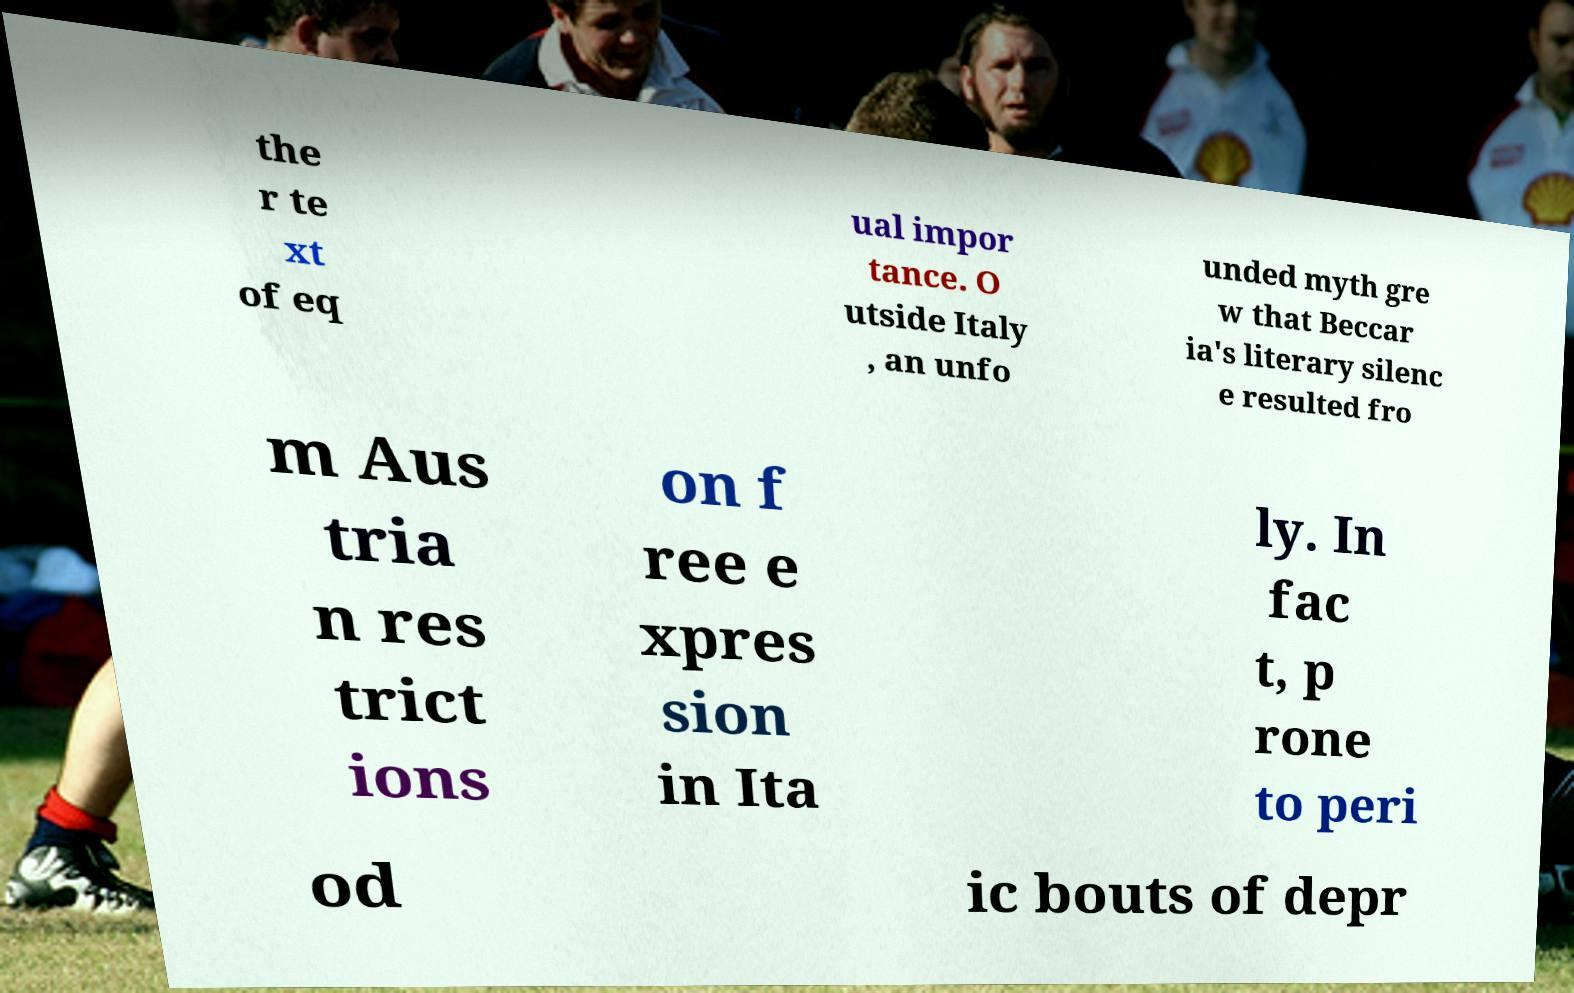Can you read and provide the text displayed in the image?This photo seems to have some interesting text. Can you extract and type it out for me? the r te xt of eq ual impor tance. O utside Italy , an unfo unded myth gre w that Beccar ia's literary silenc e resulted fro m Aus tria n res trict ions on f ree e xpres sion in Ita ly. In fac t, p rone to peri od ic bouts of depr 